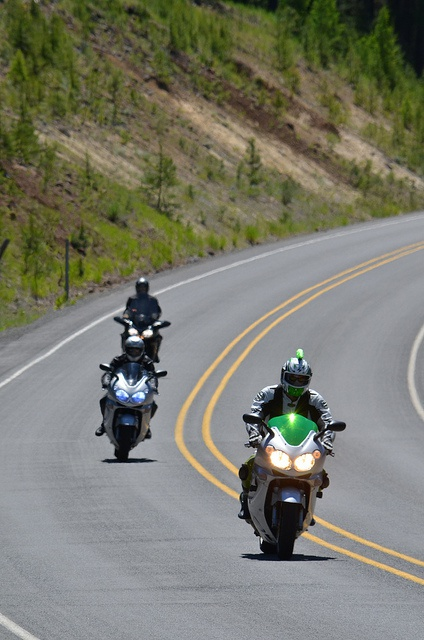Describe the objects in this image and their specific colors. I can see motorcycle in black, gray, white, and green tones, motorcycle in black, gray, navy, and white tones, people in black, gray, darkgray, and lightgray tones, people in black, gray, and darkgray tones, and motorcycle in black, gray, white, and darkgray tones in this image. 